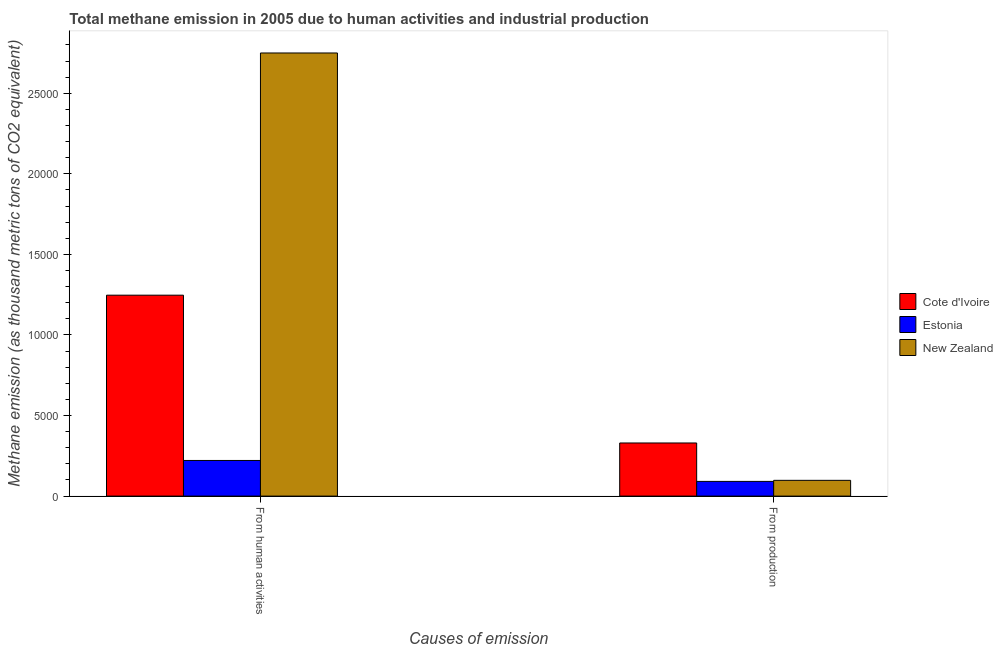How many groups of bars are there?
Provide a succinct answer. 2. How many bars are there on the 2nd tick from the left?
Provide a succinct answer. 3. What is the label of the 2nd group of bars from the left?
Keep it short and to the point. From production. What is the amount of emissions from human activities in Cote d'Ivoire?
Provide a short and direct response. 1.25e+04. Across all countries, what is the maximum amount of emissions generated from industries?
Your response must be concise. 3298.2. Across all countries, what is the minimum amount of emissions from human activities?
Ensure brevity in your answer.  2212.3. In which country was the amount of emissions from human activities maximum?
Give a very brief answer. New Zealand. In which country was the amount of emissions generated from industries minimum?
Provide a short and direct response. Estonia. What is the total amount of emissions generated from industries in the graph?
Your answer should be very brief. 5191.1. What is the difference between the amount of emissions from human activities in Cote d'Ivoire and that in New Zealand?
Your answer should be very brief. -1.50e+04. What is the difference between the amount of emissions from human activities in Cote d'Ivoire and the amount of emissions generated from industries in New Zealand?
Give a very brief answer. 1.15e+04. What is the average amount of emissions generated from industries per country?
Ensure brevity in your answer.  1730.37. What is the difference between the amount of emissions generated from industries and amount of emissions from human activities in Cote d'Ivoire?
Provide a succinct answer. -9173.3. In how many countries, is the amount of emissions generated from industries greater than 20000 thousand metric tons?
Provide a succinct answer. 0. What is the ratio of the amount of emissions generated from industries in Estonia to that in Cote d'Ivoire?
Provide a succinct answer. 0.28. Is the amount of emissions from human activities in Cote d'Ivoire less than that in New Zealand?
Your response must be concise. Yes. What does the 2nd bar from the left in From production represents?
Your answer should be compact. Estonia. What does the 3rd bar from the right in From production represents?
Give a very brief answer. Cote d'Ivoire. How many bars are there?
Make the answer very short. 6. Are all the bars in the graph horizontal?
Your answer should be very brief. No. How many countries are there in the graph?
Give a very brief answer. 3. What is the difference between two consecutive major ticks on the Y-axis?
Provide a succinct answer. 5000. Are the values on the major ticks of Y-axis written in scientific E-notation?
Offer a very short reply. No. Does the graph contain any zero values?
Provide a short and direct response. No. Does the graph contain grids?
Provide a short and direct response. No. How are the legend labels stacked?
Provide a succinct answer. Vertical. What is the title of the graph?
Your response must be concise. Total methane emission in 2005 due to human activities and industrial production. Does "Colombia" appear as one of the legend labels in the graph?
Offer a terse response. No. What is the label or title of the X-axis?
Give a very brief answer. Causes of emission. What is the label or title of the Y-axis?
Keep it short and to the point. Methane emission (as thousand metric tons of CO2 equivalent). What is the Methane emission (as thousand metric tons of CO2 equivalent) of Cote d'Ivoire in From human activities?
Your answer should be compact. 1.25e+04. What is the Methane emission (as thousand metric tons of CO2 equivalent) of Estonia in From human activities?
Provide a succinct answer. 2212.3. What is the Methane emission (as thousand metric tons of CO2 equivalent) of New Zealand in From human activities?
Offer a very short reply. 2.75e+04. What is the Methane emission (as thousand metric tons of CO2 equivalent) in Cote d'Ivoire in From production?
Your answer should be compact. 3298.2. What is the Methane emission (as thousand metric tons of CO2 equivalent) of Estonia in From production?
Provide a short and direct response. 913.5. What is the Methane emission (as thousand metric tons of CO2 equivalent) of New Zealand in From production?
Offer a terse response. 979.4. Across all Causes of emission, what is the maximum Methane emission (as thousand metric tons of CO2 equivalent) of Cote d'Ivoire?
Offer a very short reply. 1.25e+04. Across all Causes of emission, what is the maximum Methane emission (as thousand metric tons of CO2 equivalent) of Estonia?
Offer a very short reply. 2212.3. Across all Causes of emission, what is the maximum Methane emission (as thousand metric tons of CO2 equivalent) of New Zealand?
Offer a very short reply. 2.75e+04. Across all Causes of emission, what is the minimum Methane emission (as thousand metric tons of CO2 equivalent) in Cote d'Ivoire?
Your answer should be very brief. 3298.2. Across all Causes of emission, what is the minimum Methane emission (as thousand metric tons of CO2 equivalent) in Estonia?
Provide a short and direct response. 913.5. Across all Causes of emission, what is the minimum Methane emission (as thousand metric tons of CO2 equivalent) in New Zealand?
Keep it short and to the point. 979.4. What is the total Methane emission (as thousand metric tons of CO2 equivalent) of Cote d'Ivoire in the graph?
Offer a terse response. 1.58e+04. What is the total Methane emission (as thousand metric tons of CO2 equivalent) in Estonia in the graph?
Offer a terse response. 3125.8. What is the total Methane emission (as thousand metric tons of CO2 equivalent) of New Zealand in the graph?
Your answer should be very brief. 2.85e+04. What is the difference between the Methane emission (as thousand metric tons of CO2 equivalent) of Cote d'Ivoire in From human activities and that in From production?
Keep it short and to the point. 9173.3. What is the difference between the Methane emission (as thousand metric tons of CO2 equivalent) of Estonia in From human activities and that in From production?
Provide a succinct answer. 1298.8. What is the difference between the Methane emission (as thousand metric tons of CO2 equivalent) of New Zealand in From human activities and that in From production?
Ensure brevity in your answer.  2.65e+04. What is the difference between the Methane emission (as thousand metric tons of CO2 equivalent) of Cote d'Ivoire in From human activities and the Methane emission (as thousand metric tons of CO2 equivalent) of Estonia in From production?
Keep it short and to the point. 1.16e+04. What is the difference between the Methane emission (as thousand metric tons of CO2 equivalent) of Cote d'Ivoire in From human activities and the Methane emission (as thousand metric tons of CO2 equivalent) of New Zealand in From production?
Ensure brevity in your answer.  1.15e+04. What is the difference between the Methane emission (as thousand metric tons of CO2 equivalent) in Estonia in From human activities and the Methane emission (as thousand metric tons of CO2 equivalent) in New Zealand in From production?
Provide a short and direct response. 1232.9. What is the average Methane emission (as thousand metric tons of CO2 equivalent) of Cote d'Ivoire per Causes of emission?
Provide a short and direct response. 7884.85. What is the average Methane emission (as thousand metric tons of CO2 equivalent) in Estonia per Causes of emission?
Offer a very short reply. 1562.9. What is the average Methane emission (as thousand metric tons of CO2 equivalent) of New Zealand per Causes of emission?
Provide a short and direct response. 1.42e+04. What is the difference between the Methane emission (as thousand metric tons of CO2 equivalent) of Cote d'Ivoire and Methane emission (as thousand metric tons of CO2 equivalent) of Estonia in From human activities?
Your response must be concise. 1.03e+04. What is the difference between the Methane emission (as thousand metric tons of CO2 equivalent) in Cote d'Ivoire and Methane emission (as thousand metric tons of CO2 equivalent) in New Zealand in From human activities?
Your answer should be very brief. -1.50e+04. What is the difference between the Methane emission (as thousand metric tons of CO2 equivalent) of Estonia and Methane emission (as thousand metric tons of CO2 equivalent) of New Zealand in From human activities?
Keep it short and to the point. -2.53e+04. What is the difference between the Methane emission (as thousand metric tons of CO2 equivalent) in Cote d'Ivoire and Methane emission (as thousand metric tons of CO2 equivalent) in Estonia in From production?
Offer a very short reply. 2384.7. What is the difference between the Methane emission (as thousand metric tons of CO2 equivalent) of Cote d'Ivoire and Methane emission (as thousand metric tons of CO2 equivalent) of New Zealand in From production?
Your response must be concise. 2318.8. What is the difference between the Methane emission (as thousand metric tons of CO2 equivalent) in Estonia and Methane emission (as thousand metric tons of CO2 equivalent) in New Zealand in From production?
Your answer should be very brief. -65.9. What is the ratio of the Methane emission (as thousand metric tons of CO2 equivalent) in Cote d'Ivoire in From human activities to that in From production?
Your answer should be compact. 3.78. What is the ratio of the Methane emission (as thousand metric tons of CO2 equivalent) in Estonia in From human activities to that in From production?
Provide a succinct answer. 2.42. What is the ratio of the Methane emission (as thousand metric tons of CO2 equivalent) in New Zealand in From human activities to that in From production?
Make the answer very short. 28.08. What is the difference between the highest and the second highest Methane emission (as thousand metric tons of CO2 equivalent) of Cote d'Ivoire?
Your answer should be compact. 9173.3. What is the difference between the highest and the second highest Methane emission (as thousand metric tons of CO2 equivalent) in Estonia?
Give a very brief answer. 1298.8. What is the difference between the highest and the second highest Methane emission (as thousand metric tons of CO2 equivalent) of New Zealand?
Make the answer very short. 2.65e+04. What is the difference between the highest and the lowest Methane emission (as thousand metric tons of CO2 equivalent) of Cote d'Ivoire?
Offer a very short reply. 9173.3. What is the difference between the highest and the lowest Methane emission (as thousand metric tons of CO2 equivalent) in Estonia?
Keep it short and to the point. 1298.8. What is the difference between the highest and the lowest Methane emission (as thousand metric tons of CO2 equivalent) in New Zealand?
Offer a terse response. 2.65e+04. 